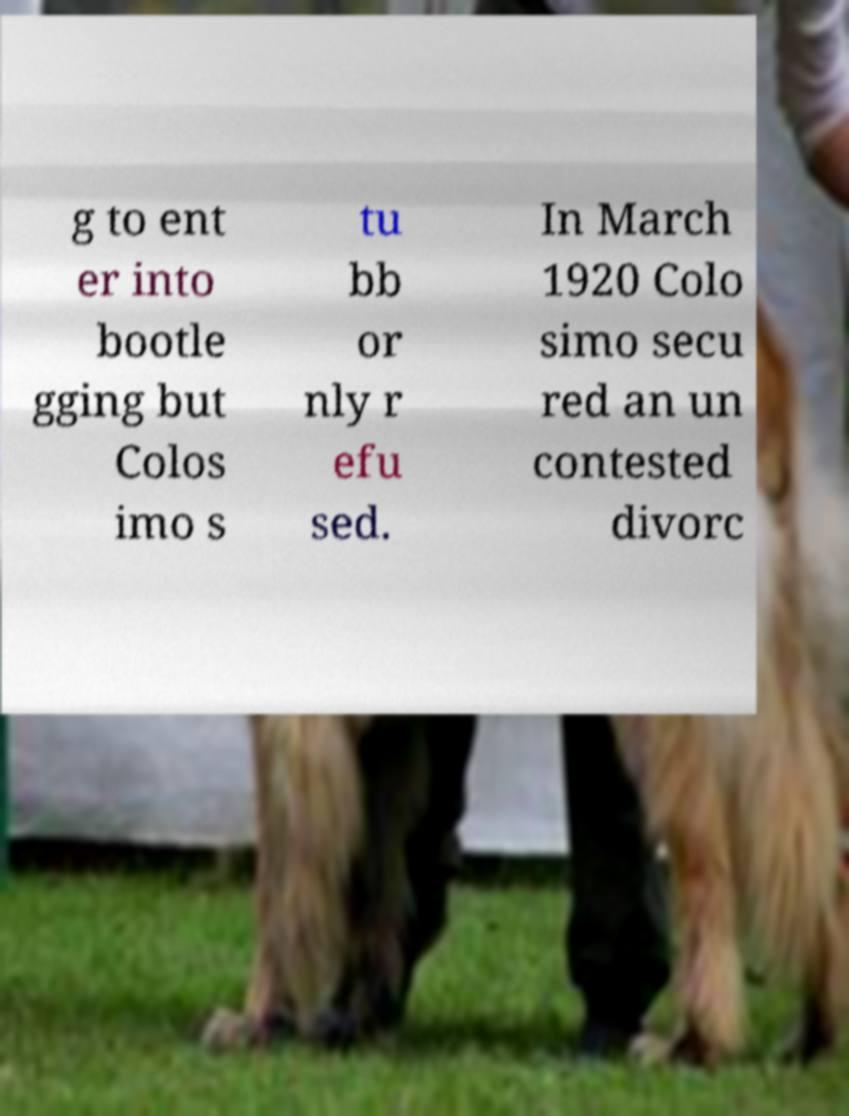Can you accurately transcribe the text from the provided image for me? g to ent er into bootle gging but Colos imo s tu bb or nly r efu sed. In March 1920 Colo simo secu red an un contested divorc 